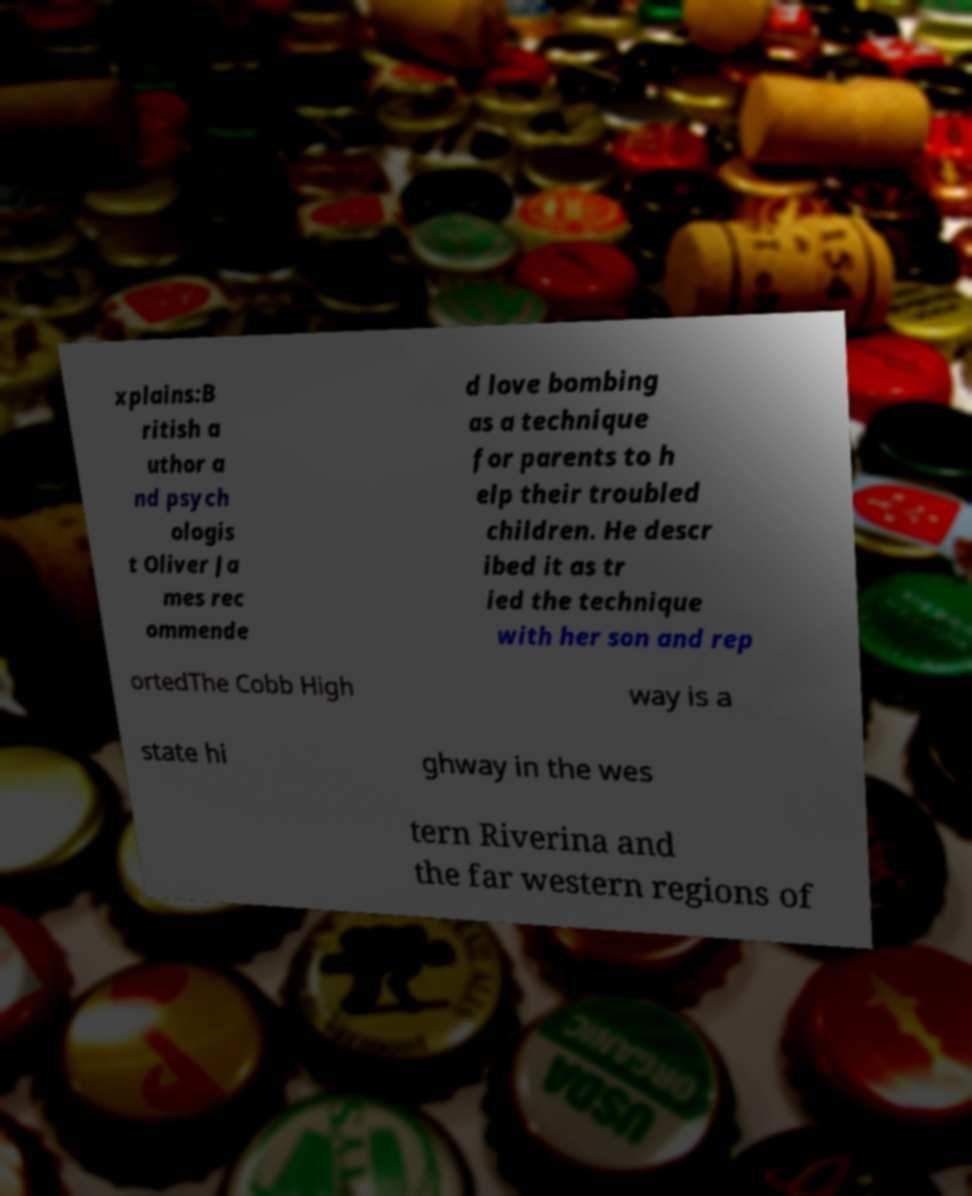Could you assist in decoding the text presented in this image and type it out clearly? xplains:B ritish a uthor a nd psych ologis t Oliver Ja mes rec ommende d love bombing as a technique for parents to h elp their troubled children. He descr ibed it as tr ied the technique with her son and rep ortedThe Cobb High way is a state hi ghway in the wes tern Riverina and the far western regions of 